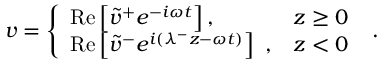<formula> <loc_0><loc_0><loc_500><loc_500>v = \left \{ \begin{array} { l l } { R e \left [ \tilde { v } ^ { + } e ^ { - i \omega t } \right ] , } & { z \geq 0 } \\ { R e \left [ \tilde { v } ^ { - } e ^ { i ( \lambda ^ { - } z - \omega t ) } \right ] , } & { z < 0 } \end{array} .</formula> 